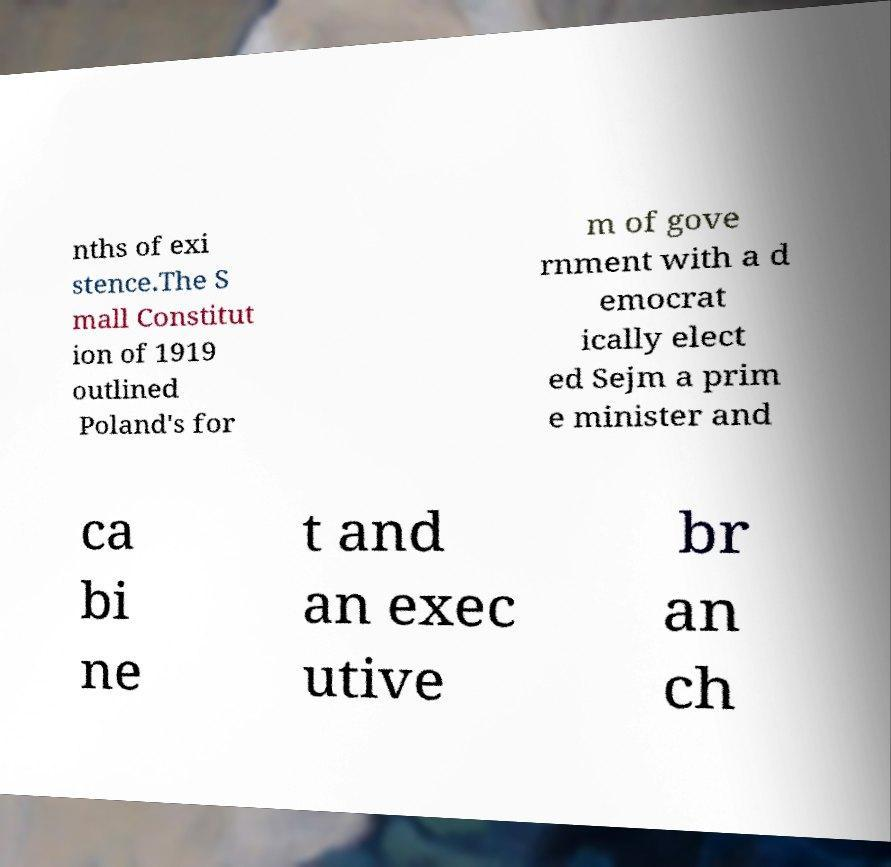Can you read and provide the text displayed in the image?This photo seems to have some interesting text. Can you extract and type it out for me? nths of exi stence.The S mall Constitut ion of 1919 outlined Poland's for m of gove rnment with a d emocrat ically elect ed Sejm a prim e minister and ca bi ne t and an exec utive br an ch 